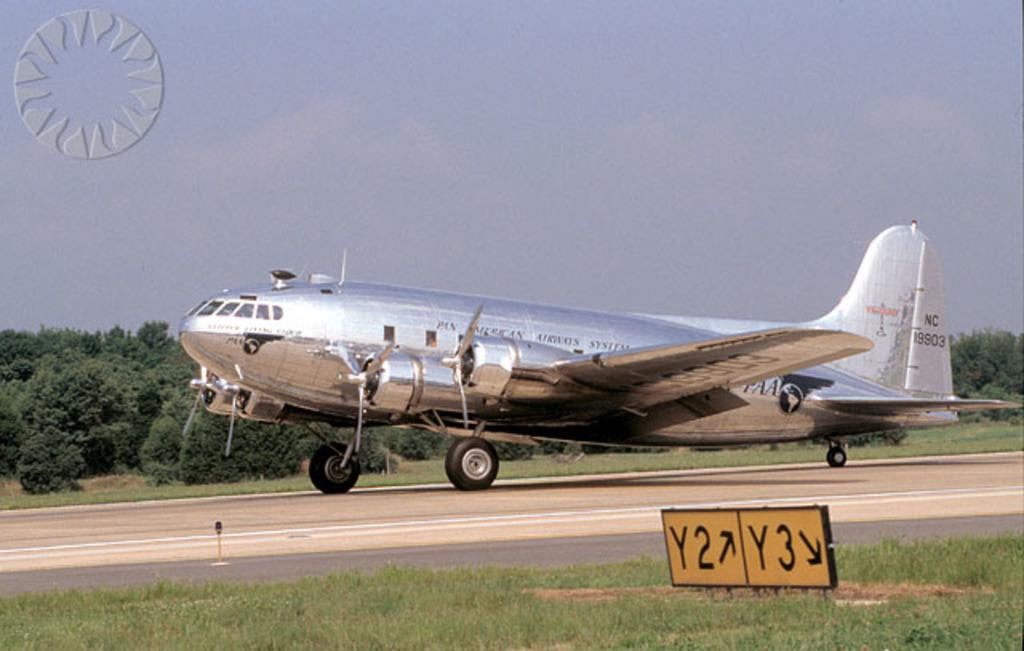<image>
Describe the image concisely. A silver Pan American Airways System's aircraft on the runway. 